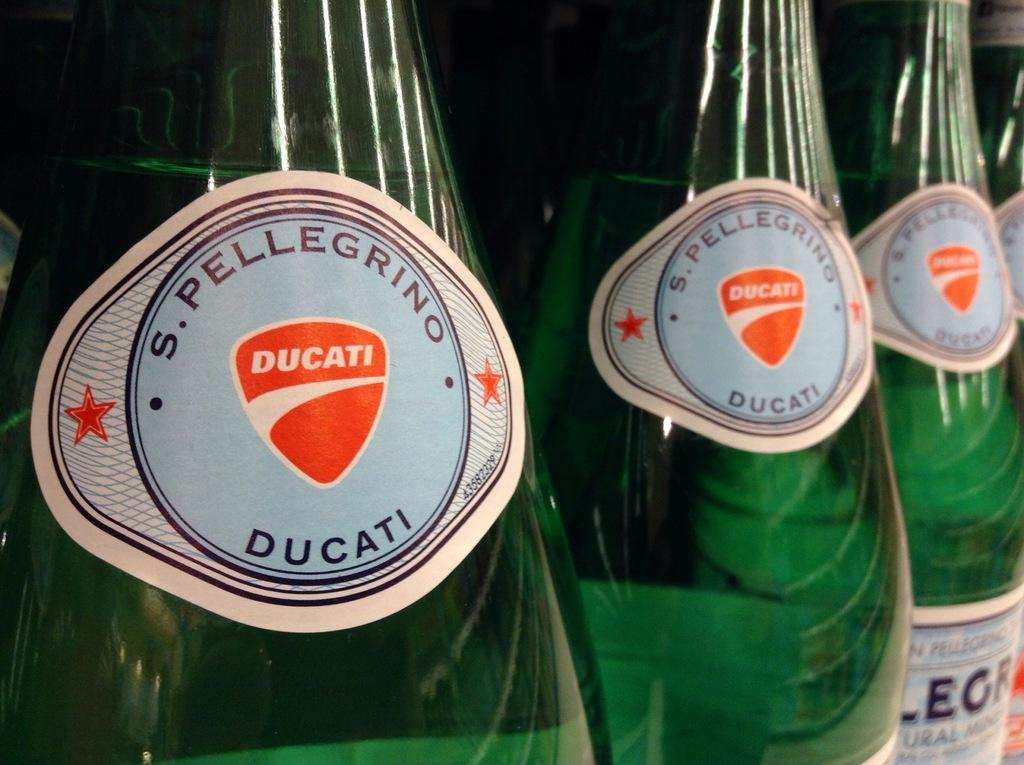What objects are present in the image? There are bottles in the image. What type of structure can be seen in the background of the image? There is no background or structure visible in the image; it only shows bottles. What memory does the image evoke for the viewer? The image does not evoke any specific memory, as it only contains bottles and no other context or personal connection. 